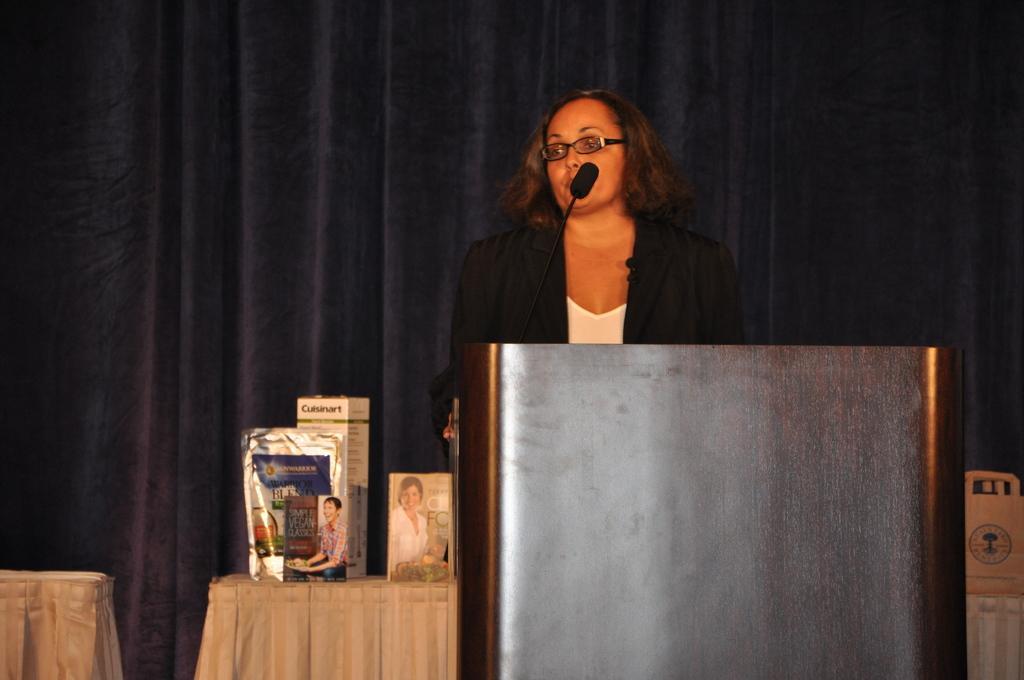Please provide a concise description of this image. In this picture we can see a woman standing and talking in front of the mike, side we can see some boxes are placed on the table, behind we can see the curtain. 